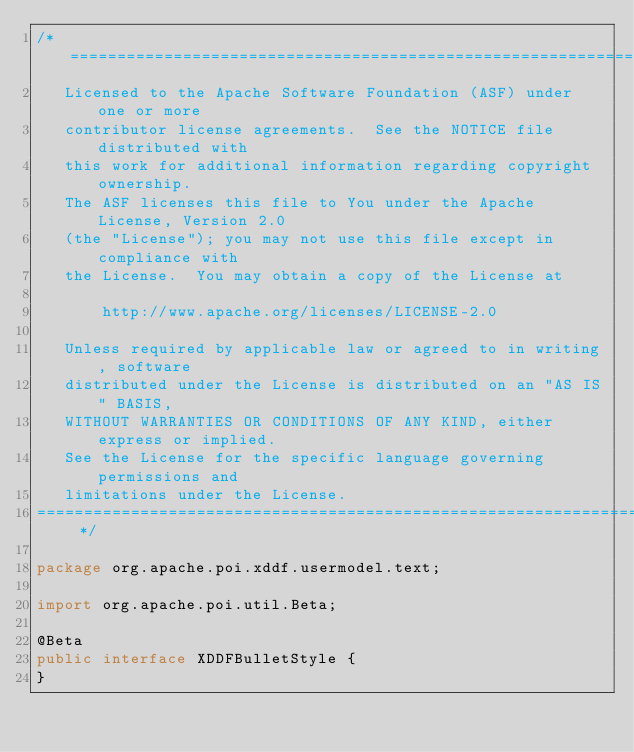<code> <loc_0><loc_0><loc_500><loc_500><_Java_>/* ====================================================================
   Licensed to the Apache Software Foundation (ASF) under one or more
   contributor license agreements.  See the NOTICE file distributed with
   this work for additional information regarding copyright ownership.
   The ASF licenses this file to You under the Apache License, Version 2.0
   (the "License"); you may not use this file except in compliance with
   the License.  You may obtain a copy of the License at

       http://www.apache.org/licenses/LICENSE-2.0

   Unless required by applicable law or agreed to in writing, software
   distributed under the License is distributed on an "AS IS" BASIS,
   WITHOUT WARRANTIES OR CONDITIONS OF ANY KIND, either express or implied.
   See the License for the specific language governing permissions and
   limitations under the License.
==================================================================== */

package org.apache.poi.xddf.usermodel.text;

import org.apache.poi.util.Beta;

@Beta
public interface XDDFBulletStyle {
}
</code> 